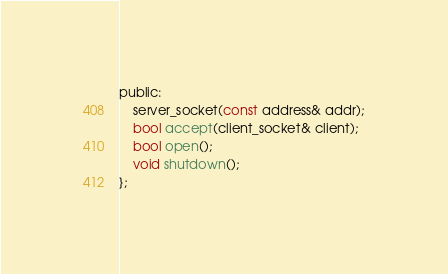Convert code to text. <code><loc_0><loc_0><loc_500><loc_500><_C_>
public:
    server_socket(const address& addr);
    bool accept(client_socket& client);
    bool open();
    void shutdown();
};</code> 